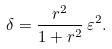Convert formula to latex. <formula><loc_0><loc_0><loc_500><loc_500>\delta = \frac { r ^ { 2 } } { 1 + r ^ { 2 } } \, \varepsilon ^ { 2 } .</formula> 